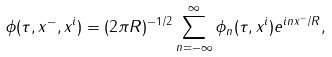<formula> <loc_0><loc_0><loc_500><loc_500>\phi ( \tau , x ^ { - } , x ^ { i } ) = ( 2 \pi R ) ^ { - 1 / 2 } \sum _ { n = - \infty } ^ { \infty } \phi _ { n } ( \tau , x ^ { i } ) e ^ { i n x ^ { - } / R } ,</formula> 